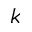Convert formula to latex. <formula><loc_0><loc_0><loc_500><loc_500>k</formula> 